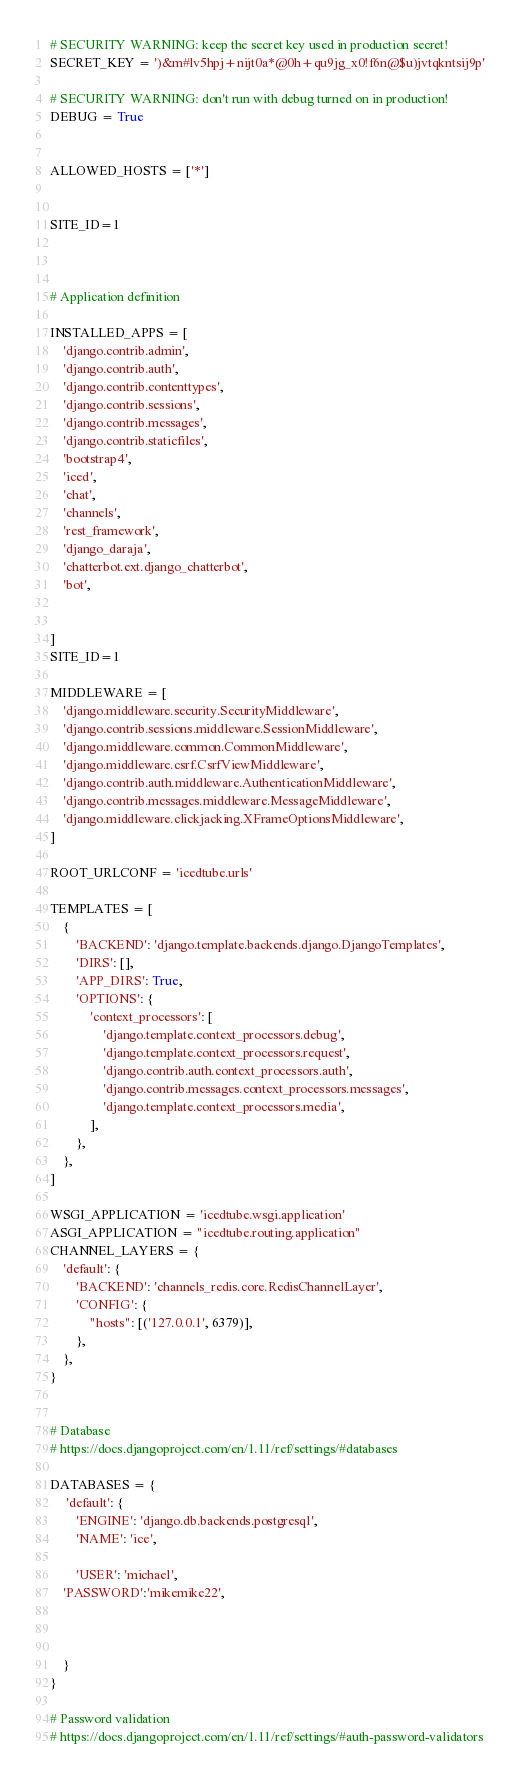<code> <loc_0><loc_0><loc_500><loc_500><_Python_>
# SECURITY WARNING: keep the secret key used in production secret!
SECRET_KEY = ')&m#lv5hpj+nijt0a*@0h+qu9jg_x0!f6n@$u)jvtqkntsij9p'

# SECURITY WARNING: don't run with debug turned on in production!
DEBUG = True


ALLOWED_HOSTS = ['*']


SITE_ID=1



# Application definition

INSTALLED_APPS = [
    'django.contrib.admin',
    'django.contrib.auth',
    'django.contrib.contenttypes',
    'django.contrib.sessions',
    'django.contrib.messages',
    'django.contrib.staticfiles',
    'bootstrap4',
    'iced',
    'chat',
    'channels',
    'rest_framework',
    'django_daraja',
    'chatterbot.ext.django_chatterbot',
    'bot',


]
SITE_ID=1

MIDDLEWARE = [
    'django.middleware.security.SecurityMiddleware',
    'django.contrib.sessions.middleware.SessionMiddleware',
    'django.middleware.common.CommonMiddleware',
    'django.middleware.csrf.CsrfViewMiddleware',
    'django.contrib.auth.middleware.AuthenticationMiddleware',
    'django.contrib.messages.middleware.MessageMiddleware',
    'django.middleware.clickjacking.XFrameOptionsMiddleware',
]

ROOT_URLCONF = 'icedtube.urls'

TEMPLATES = [
    {
        'BACKEND': 'django.template.backends.django.DjangoTemplates',
        'DIRS': [],
        'APP_DIRS': True,
        'OPTIONS': {
            'context_processors': [
                'django.template.context_processors.debug',
                'django.template.context_processors.request',
                'django.contrib.auth.context_processors.auth',
                'django.contrib.messages.context_processors.messages',
                'django.template.context_processors.media',
            ],
        },
    },
]

WSGI_APPLICATION = 'icedtube.wsgi.application'
ASGI_APPLICATION = "icedtube.routing.application"
CHANNEL_LAYERS = {
    'default': {
        'BACKEND': 'channels_redis.core.RedisChannelLayer',
        'CONFIG': {
            "hosts": [('127.0.0.1', 6379)],
        },
    },
}


# Database
# https://docs.djangoproject.com/en/1.11/ref/settings/#databases

DATABASES = {
     'default': {
        'ENGINE': 'django.db.backends.postgresql',
        'NAME': 'ice',

        'USER': 'michael',
    'PASSWORD':'mikemike22',



    }
}

# Password validation
# https://docs.djangoproject.com/en/1.11/ref/settings/#auth-password-validators

</code> 